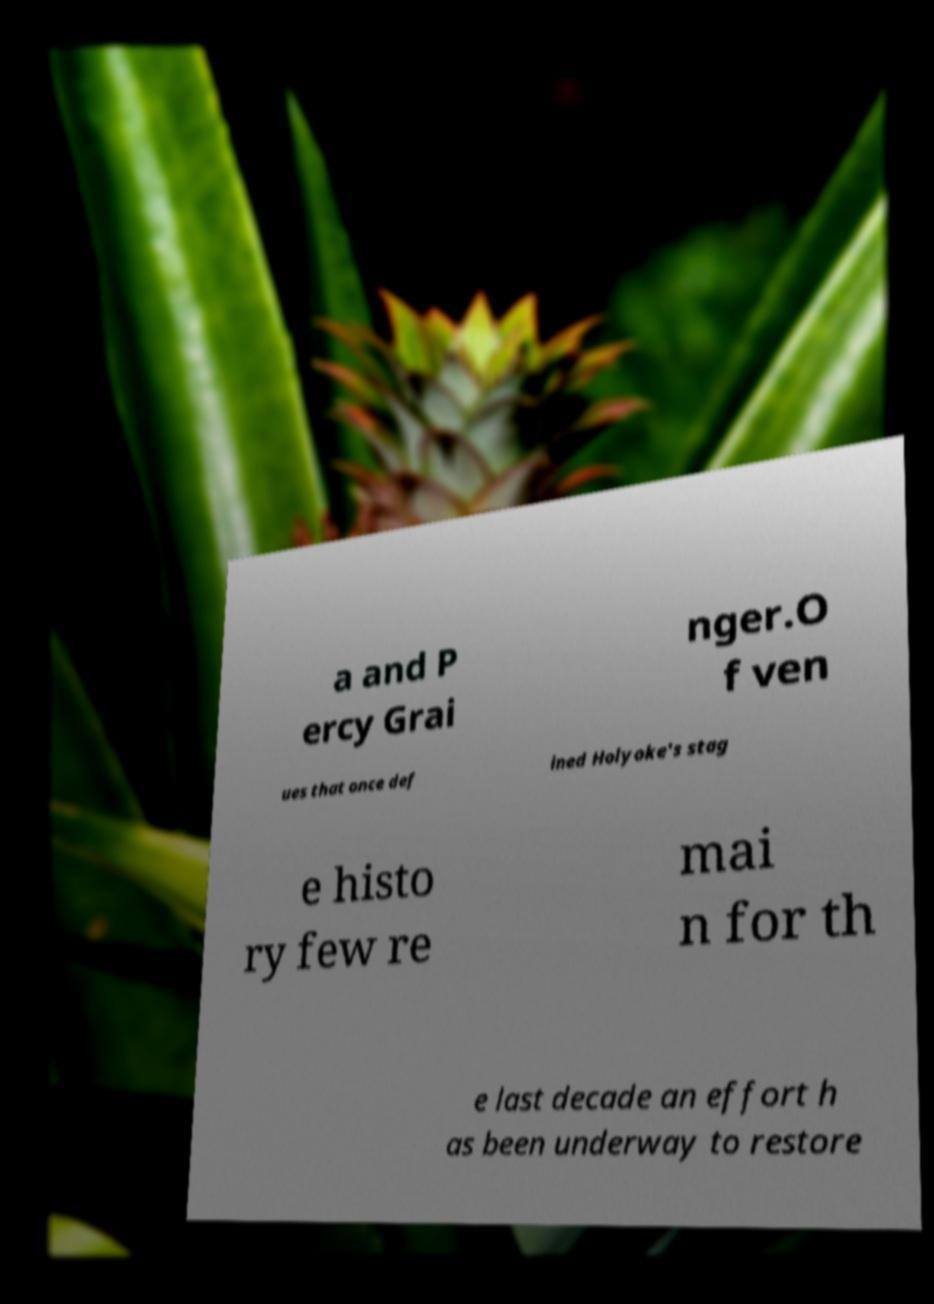Please read and relay the text visible in this image. What does it say? a and P ercy Grai nger.O f ven ues that once def ined Holyoke's stag e histo ry few re mai n for th e last decade an effort h as been underway to restore 